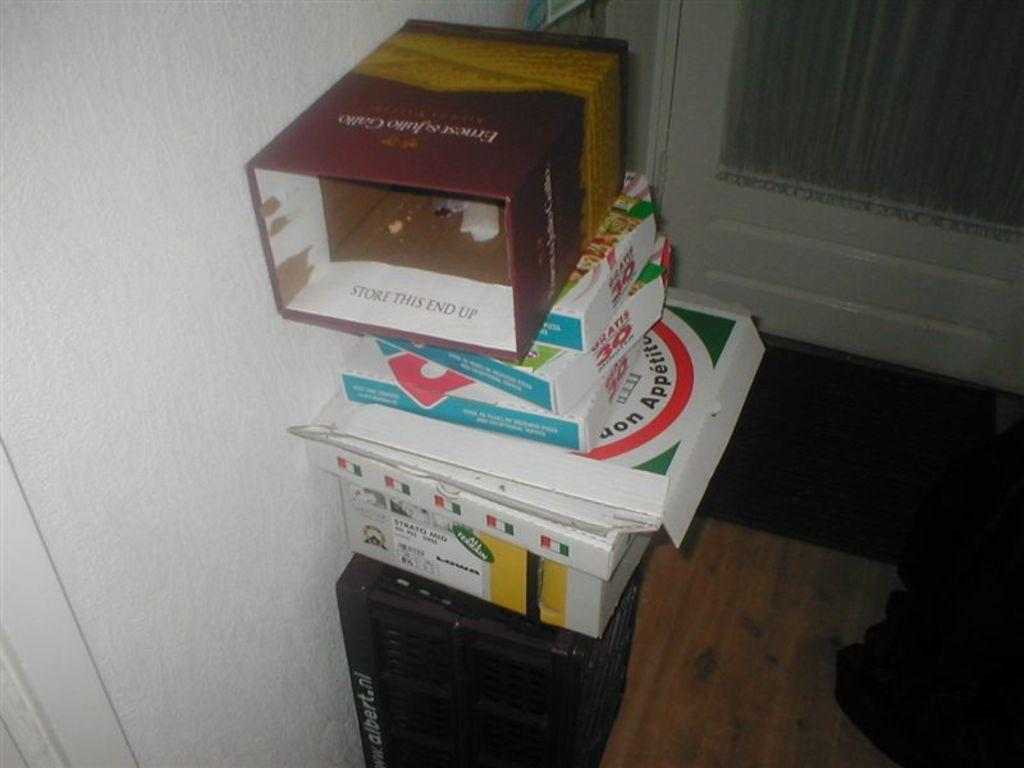<image>
Present a compact description of the photo's key features. a stack of boxes with one of them that says 'store this end up' on the side of one 